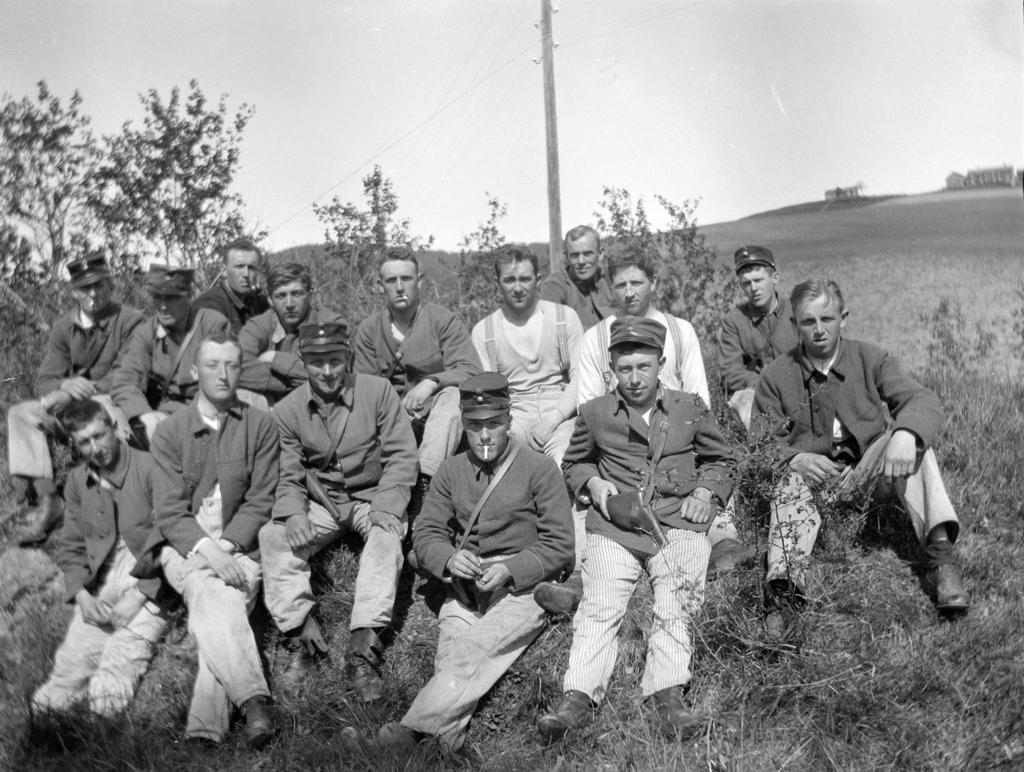What is the color scheme of the image? The image is black and white. What are the people in the image doing? People are sitting on the ground in the image. What type of vegetation can be seen in the image? There are plants, grass, and trees in the image. What is the background of the image? The sky is visible in the background of the image. What structure is present in the image? There is a pole in the image. What flavor of tree can be seen in the image? There is no tree with a specific flavor present in the image; trees do not have flavors. 